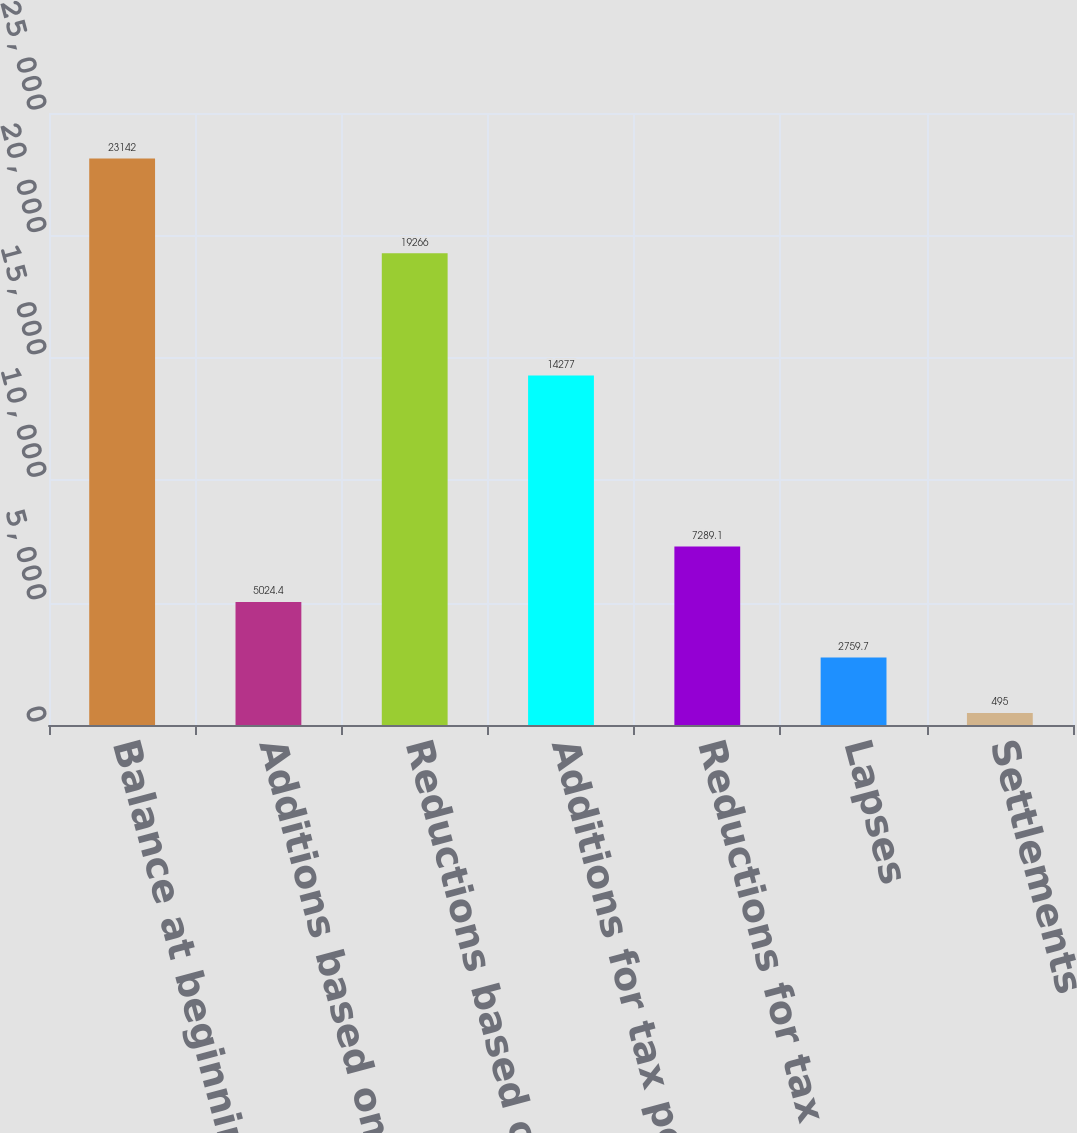Convert chart. <chart><loc_0><loc_0><loc_500><loc_500><bar_chart><fcel>Balance at beginning of year<fcel>Additions based on tax<fcel>Reductions based on tax<fcel>Additions for tax positions of<fcel>Reductions for tax positions<fcel>Lapses<fcel>Settlements<nl><fcel>23142<fcel>5024.4<fcel>19266<fcel>14277<fcel>7289.1<fcel>2759.7<fcel>495<nl></chart> 